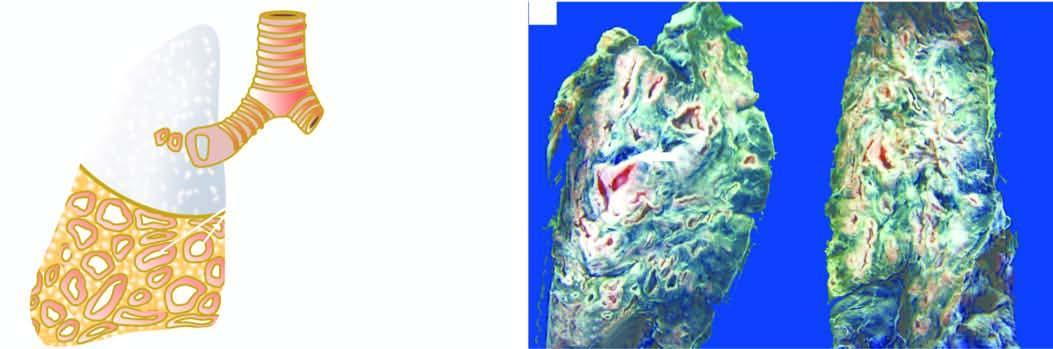re many thick-walled dilated cavities with cartilaginous wall seen?
Answer the question using a single word or phrase. Yes 